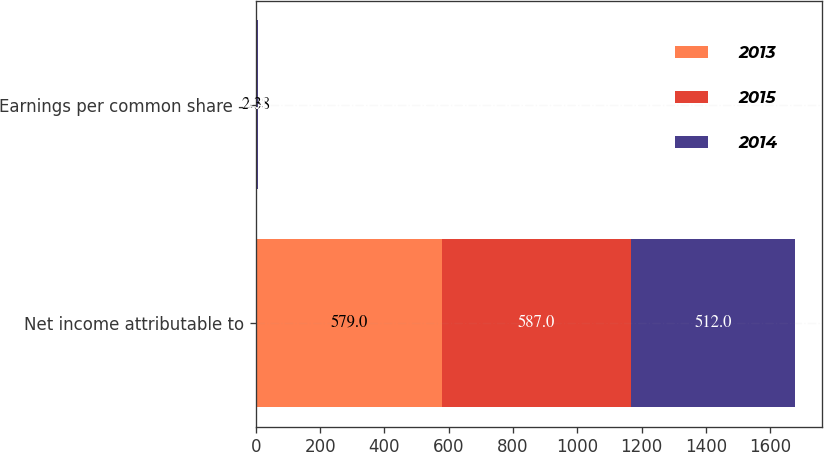Convert chart to OTSL. <chart><loc_0><loc_0><loc_500><loc_500><stacked_bar_chart><ecel><fcel>Net income attributable to<fcel>Earnings per common share -<nl><fcel>2013<fcel>579<fcel>2.38<nl><fcel>2015<fcel>587<fcel>2.4<nl><fcel>2014<fcel>512<fcel>2.1<nl></chart> 